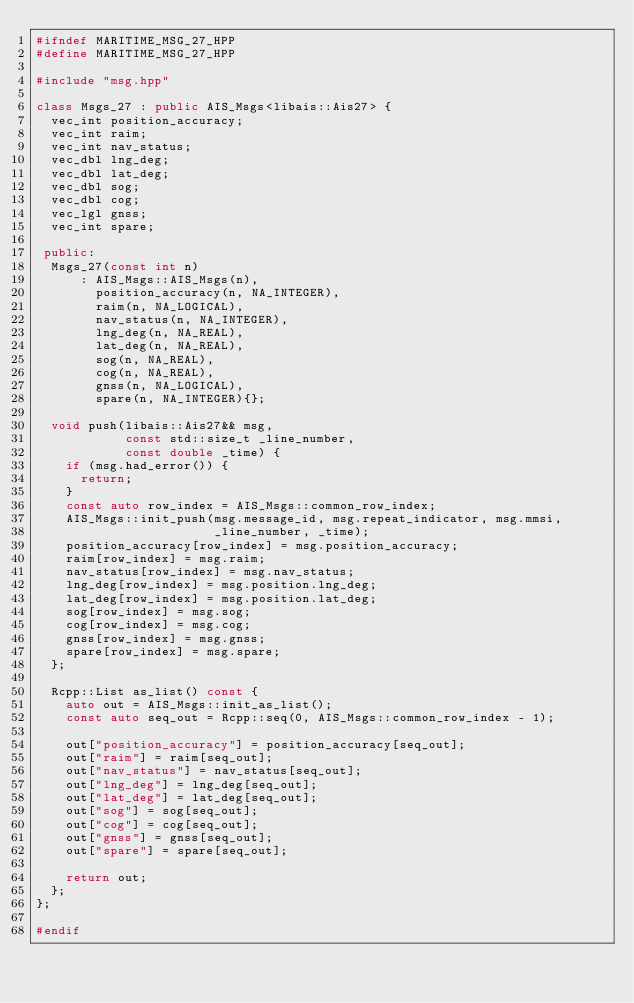Convert code to text. <code><loc_0><loc_0><loc_500><loc_500><_C++_>#ifndef MARITIME_MSG_27_HPP
#define MARITIME_MSG_27_HPP

#include "msg.hpp"

class Msgs_27 : public AIS_Msgs<libais::Ais27> {
  vec_int position_accuracy;
  vec_int raim;
  vec_int nav_status;
  vec_dbl lng_deg;
  vec_dbl lat_deg;
  vec_dbl sog;
  vec_dbl cog;
  vec_lgl gnss;
  vec_int spare;

 public:
  Msgs_27(const int n)
      : AIS_Msgs::AIS_Msgs(n),
        position_accuracy(n, NA_INTEGER),
        raim(n, NA_LOGICAL),
        nav_status(n, NA_INTEGER),
        lng_deg(n, NA_REAL),
        lat_deg(n, NA_REAL),
        sog(n, NA_REAL),
        cog(n, NA_REAL),
        gnss(n, NA_LOGICAL),
        spare(n, NA_INTEGER){};

  void push(libais::Ais27&& msg,
            const std::size_t _line_number,
            const double _time) {
    if (msg.had_error()) {
      return;
    }
    const auto row_index = AIS_Msgs::common_row_index;
    AIS_Msgs::init_push(msg.message_id, msg.repeat_indicator, msg.mmsi,
                        _line_number, _time);
    position_accuracy[row_index] = msg.position_accuracy;
    raim[row_index] = msg.raim;
    nav_status[row_index] = msg.nav_status;
    lng_deg[row_index] = msg.position.lng_deg;
    lat_deg[row_index] = msg.position.lat_deg;
    sog[row_index] = msg.sog;
    cog[row_index] = msg.cog;
    gnss[row_index] = msg.gnss;
    spare[row_index] = msg.spare;
  };

  Rcpp::List as_list() const {
    auto out = AIS_Msgs::init_as_list();
    const auto seq_out = Rcpp::seq(0, AIS_Msgs::common_row_index - 1);

    out["position_accuracy"] = position_accuracy[seq_out];
    out["raim"] = raim[seq_out];
    out["nav_status"] = nav_status[seq_out];
    out["lng_deg"] = lng_deg[seq_out];
    out["lat_deg"] = lat_deg[seq_out];
    out["sog"] = sog[seq_out];
    out["cog"] = cog[seq_out];
    out["gnss"] = gnss[seq_out];
    out["spare"] = spare[seq_out];

    return out;
  };
};

#endif
</code> 